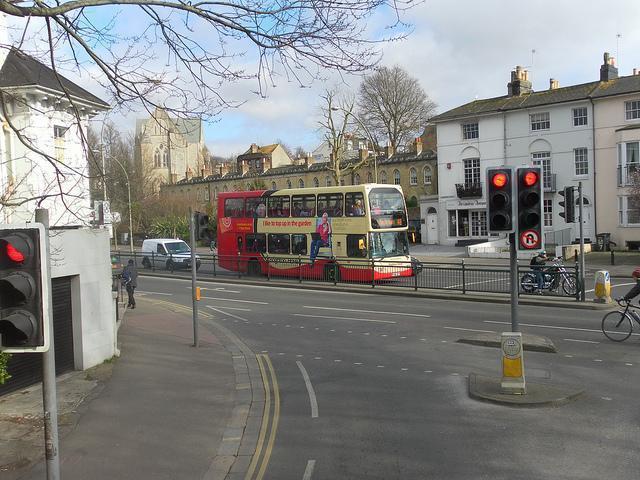How many red lights are there?
Give a very brief answer. 3. How many busses in the picture?
Give a very brief answer. 1. How many buses are on the street?
Give a very brief answer. 1. How many traffic lights are there?
Give a very brief answer. 2. How many airplanes in the photo?
Give a very brief answer. 0. 